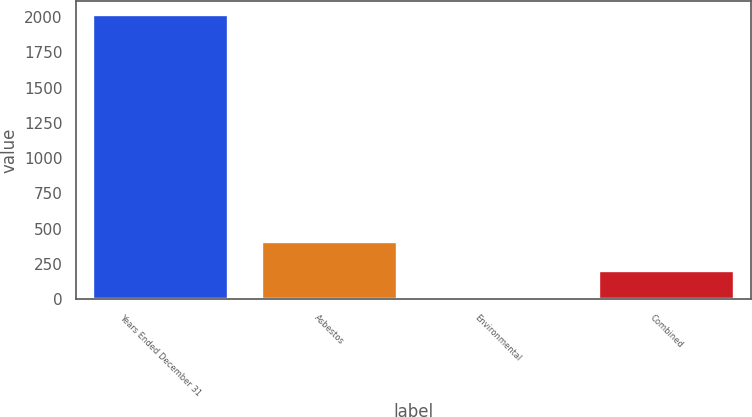Convert chart to OTSL. <chart><loc_0><loc_0><loc_500><loc_500><bar_chart><fcel>Years Ended December 31<fcel>Asbestos<fcel>Environmental<fcel>Combined<nl><fcel>2011<fcel>404.68<fcel>3.1<fcel>203.89<nl></chart> 